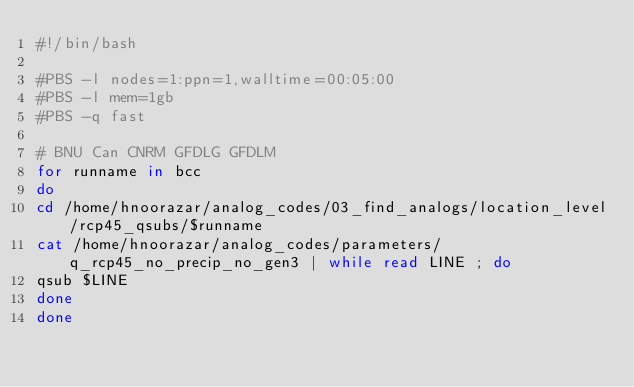Convert code to text. <code><loc_0><loc_0><loc_500><loc_500><_Bash_>#!/bin/bash

#PBS -l nodes=1:ppn=1,walltime=00:05:00
#PBS -l mem=1gb
#PBS -q fast

# BNU Can CNRM GFDLG GFDLM
for runname in bcc 
do
cd /home/hnoorazar/analog_codes/03_find_analogs/location_level/rcp45_qsubs/$runname
cat /home/hnoorazar/analog_codes/parameters/q_rcp45_no_precip_no_gen3 | while read LINE ; do
qsub $LINE
done
done
</code> 